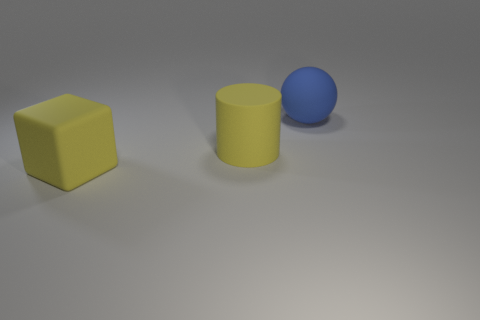Add 2 large yellow matte cylinders. How many objects exist? 5 Subtract all balls. How many objects are left? 2 Subtract all large purple shiny things. Subtract all rubber objects. How many objects are left? 0 Add 3 large objects. How many large objects are left? 6 Add 1 big blue cylinders. How many big blue cylinders exist? 1 Subtract 1 yellow cylinders. How many objects are left? 2 